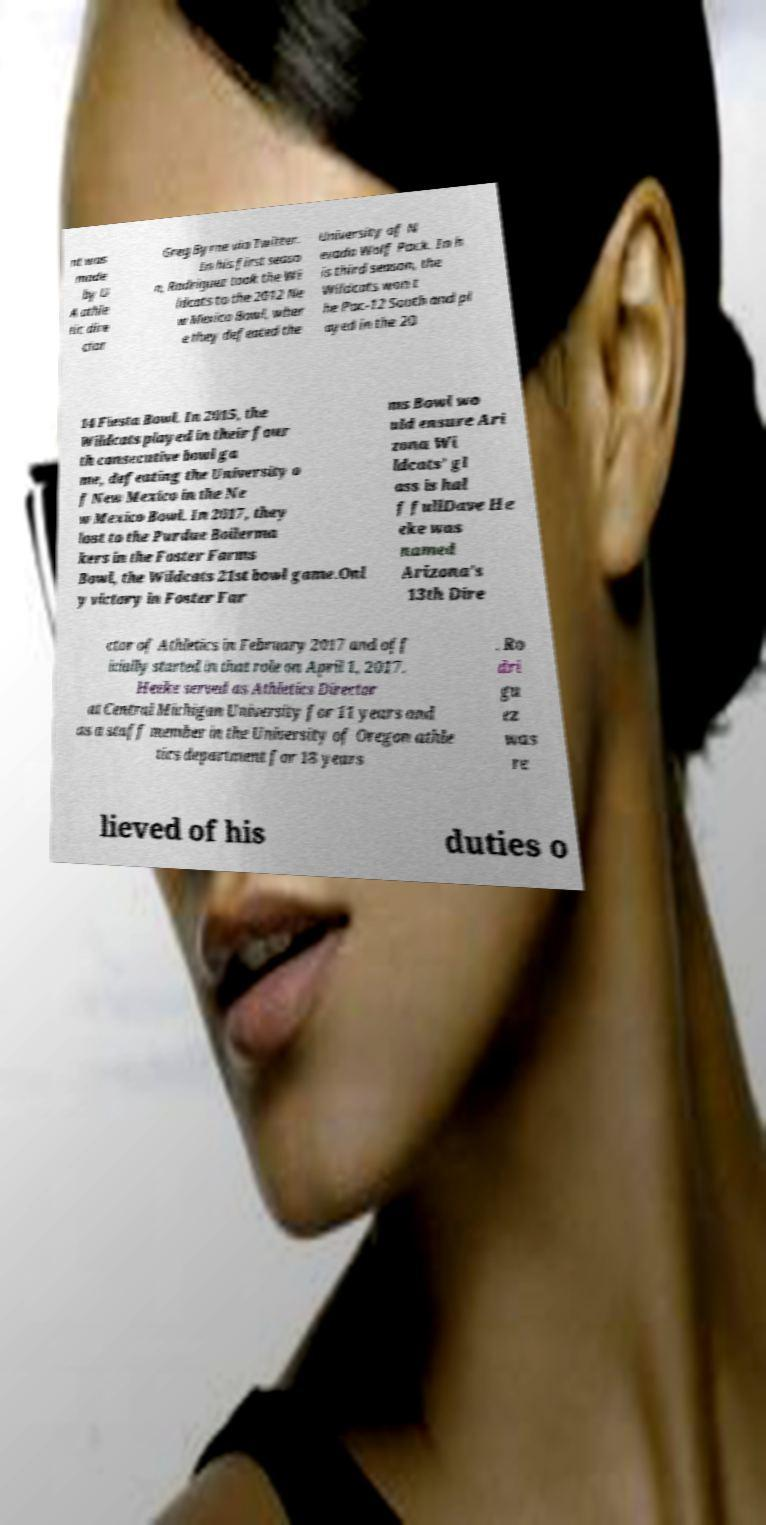Can you read and provide the text displayed in the image?This photo seems to have some interesting text. Can you extract and type it out for me? nt was made by U A athle tic dire ctor Greg Byrne via Twitter. In his first seaso n, Rodriguez took the Wi ldcats to the 2012 Ne w Mexico Bowl, wher e they defeated the University of N evada Wolf Pack. In h is third season, the Wildcats won t he Pac-12 South and pl ayed in the 20 14 Fiesta Bowl. In 2015, the Wildcats played in their four th consecutive bowl ga me, defeating the University o f New Mexico in the Ne w Mexico Bowl. In 2017, they lost to the Purdue Boilerma kers in the Foster Farms Bowl, the Wildcats 21st bowl game.Onl y victory in Foster Far ms Bowl wo uld ensure Ari zona Wi ldcats’ gl ass is hal f fullDave He eke was named Arizona's 13th Dire ctor of Athletics in February 2017 and off icially started in that role on April 1, 2017. Heeke served as Athletics Director at Central Michigan University for 11 years and as a staff member in the University of Oregon athle tics department for 18 years . Ro dri gu ez was re lieved of his duties o 